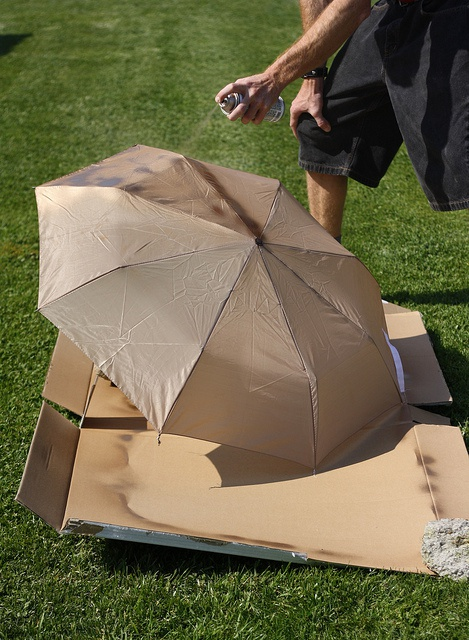Describe the objects in this image and their specific colors. I can see umbrella in darkgreen, darkgray, and gray tones and people in darkgreen, black, maroon, olive, and gray tones in this image. 